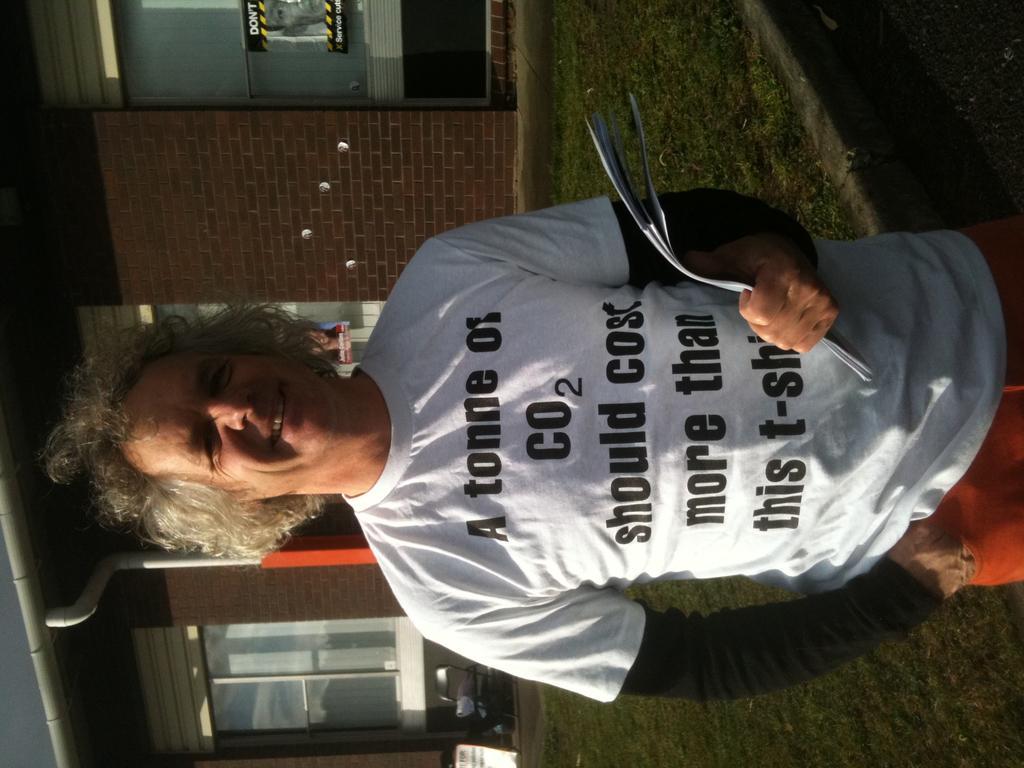In one or two sentences, can you explain what this image depicts? In the middle of the image a man is standing, smiling and holding some papers. Behind him there is grass and building, on the building there is a poster. 